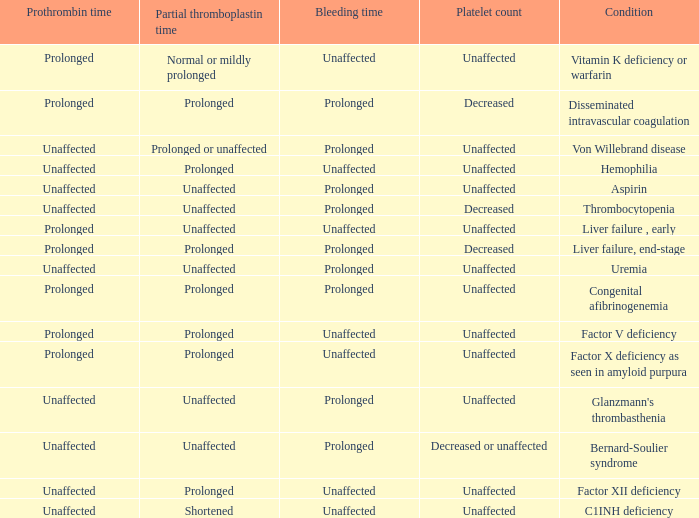Which Prothrombin time has a Platelet count of unaffected, and a Bleeding time of unaffected, and a Partial thromboplastin time of normal or mildly prolonged? Prolonged. 